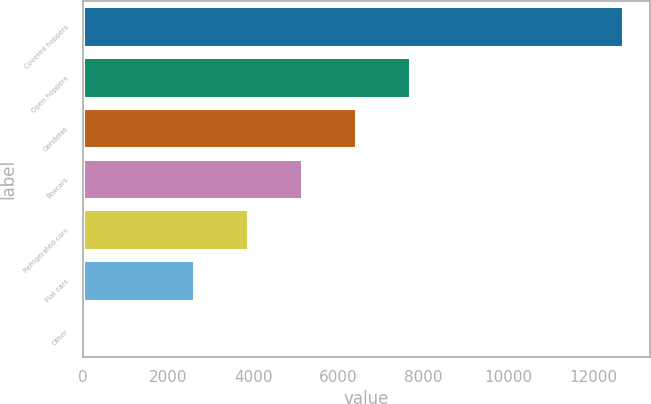Convert chart. <chart><loc_0><loc_0><loc_500><loc_500><bar_chart><fcel>Covered hoppers<fcel>Open hoppers<fcel>Gondolas<fcel>Boxcars<fcel>Refrigerated cars<fcel>Flat cars<fcel>Other<nl><fcel>12693<fcel>7681<fcel>6415<fcel>5149<fcel>3883<fcel>2617<fcel>33<nl></chart> 